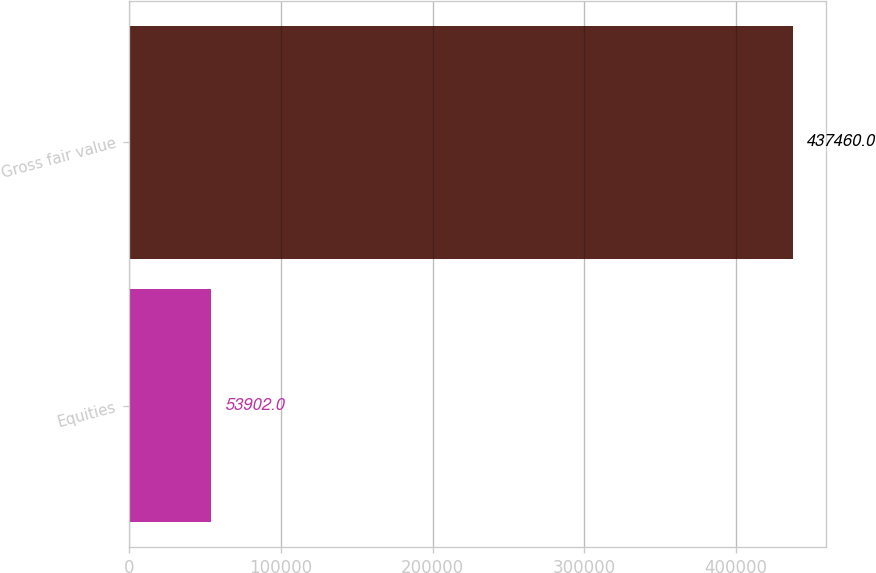<chart> <loc_0><loc_0><loc_500><loc_500><bar_chart><fcel>Equities<fcel>Gross fair value<nl><fcel>53902<fcel>437460<nl></chart> 